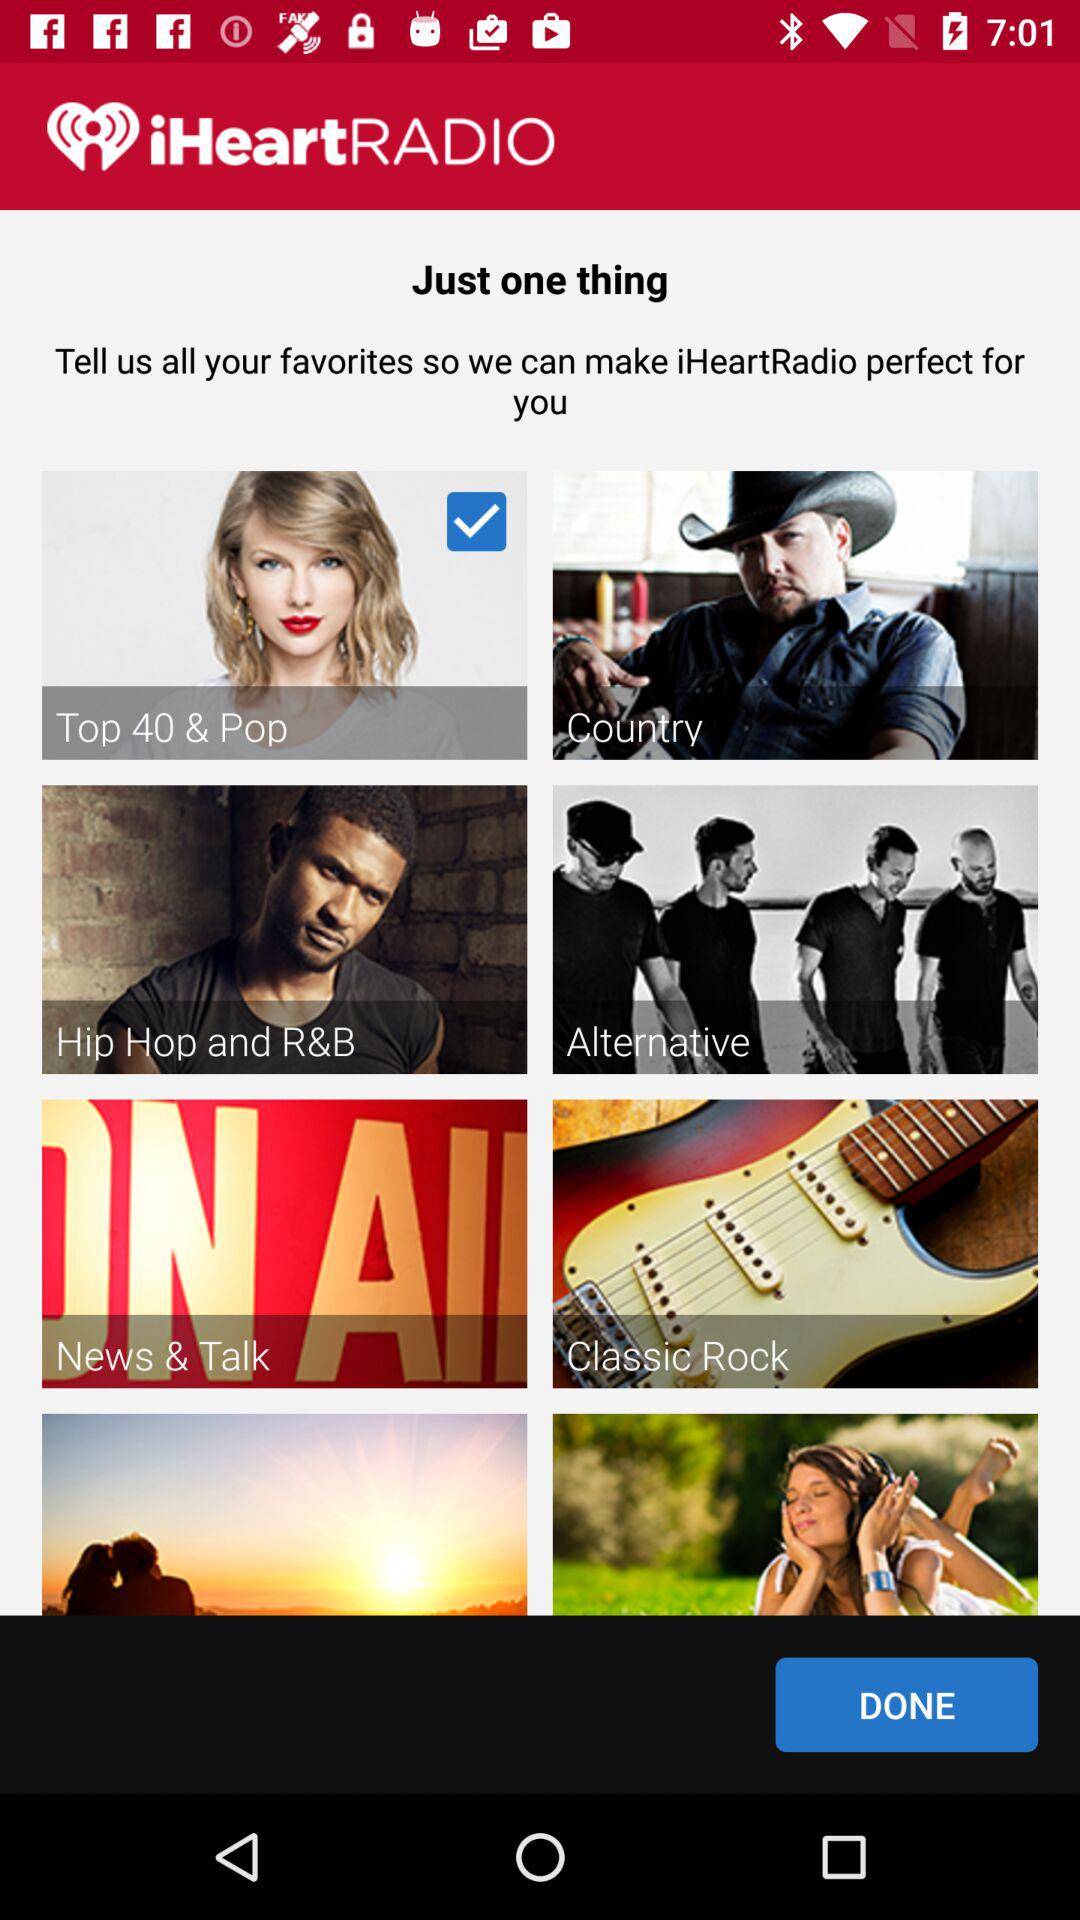What is the name of the application? The name of the application is "iHeartRADIO". 